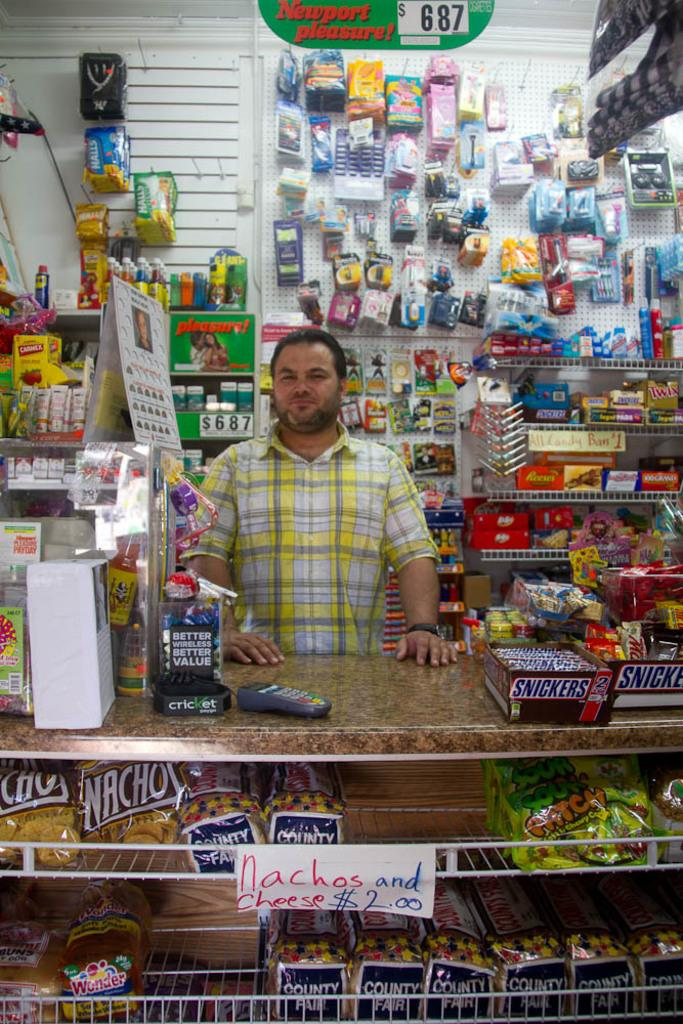<image>
Summarize the visual content of the image. A man stands behind a counter in a store where nachos and cheese are $2.00. 